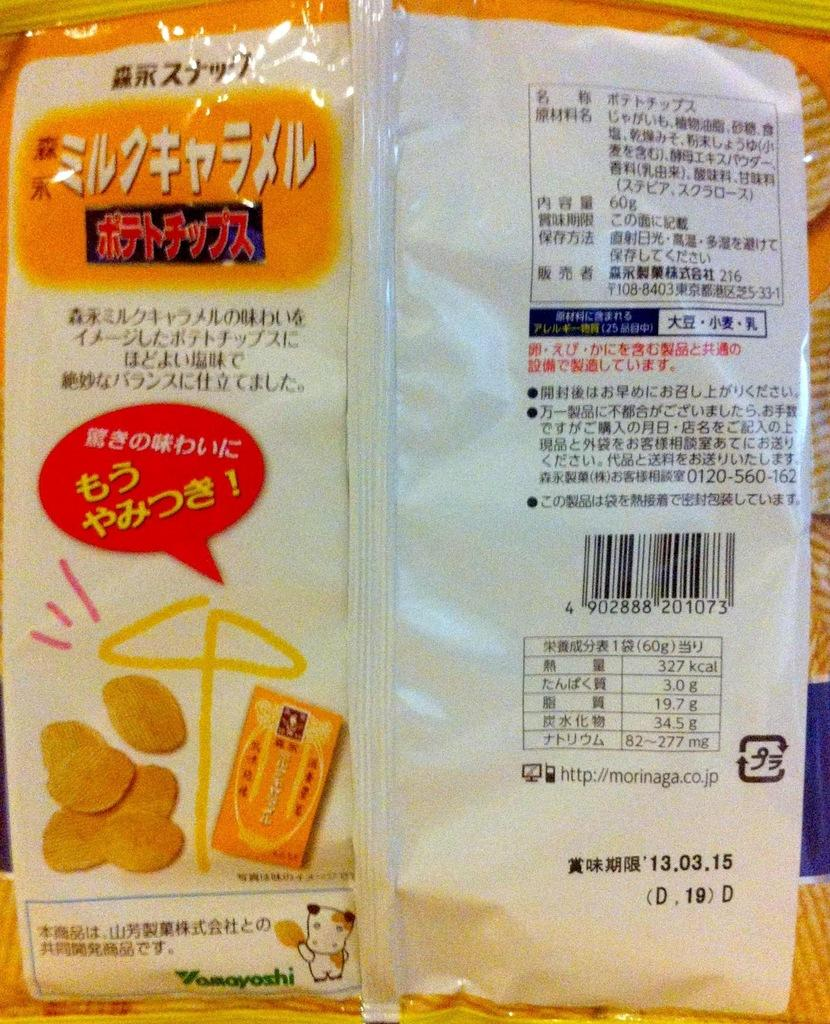What is the main object in the image? There is a cover in the image. What can be seen on the cover? The cover has pictures on it. Is there any writing on the cover? Yes, there is text written on the cover. What is the chance of the alarm going off in the image? There is no alarm present in the image, so it's not possible to determine the chance of it going off. 